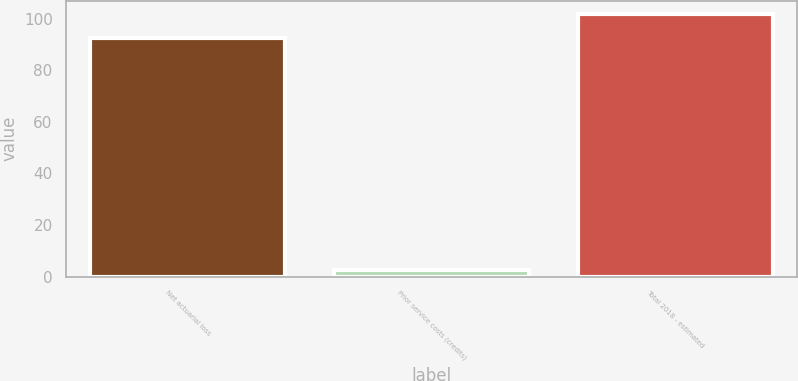<chart> <loc_0><loc_0><loc_500><loc_500><bar_chart><fcel>Net actuarial loss<fcel>Prior service costs (credits)<fcel>Total 2018 - estimated<nl><fcel>92.5<fcel>2.6<fcel>101.75<nl></chart> 